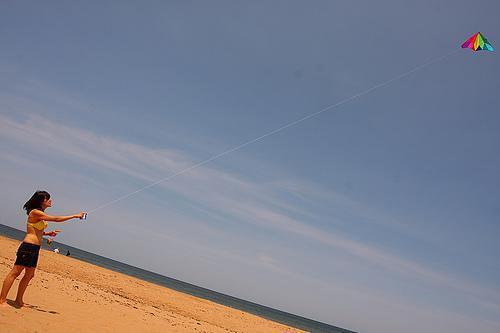How many people are there?
Give a very brief answer. 1. How many cats are shown?
Give a very brief answer. 0. How many colors is the kite?
Give a very brief answer. 5. 